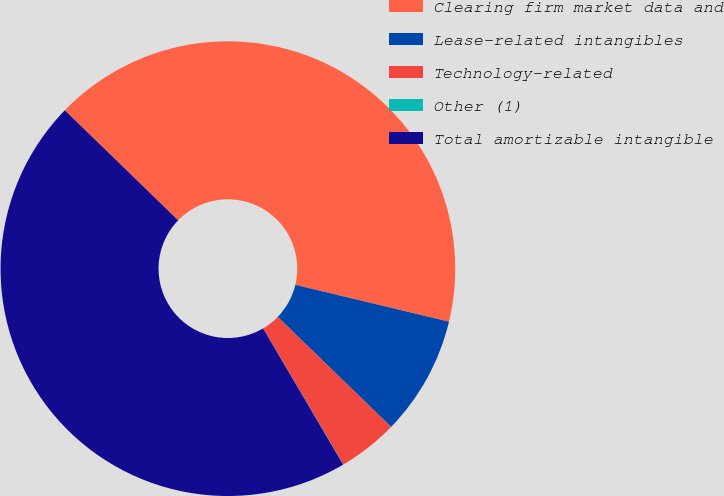Convert chart. <chart><loc_0><loc_0><loc_500><loc_500><pie_chart><fcel>Clearing firm market data and<fcel>Lease-related intangibles<fcel>Technology-related<fcel>Other (1)<fcel>Total amortizable intangible<nl><fcel>41.48%<fcel>8.51%<fcel>4.26%<fcel>0.02%<fcel>45.73%<nl></chart> 